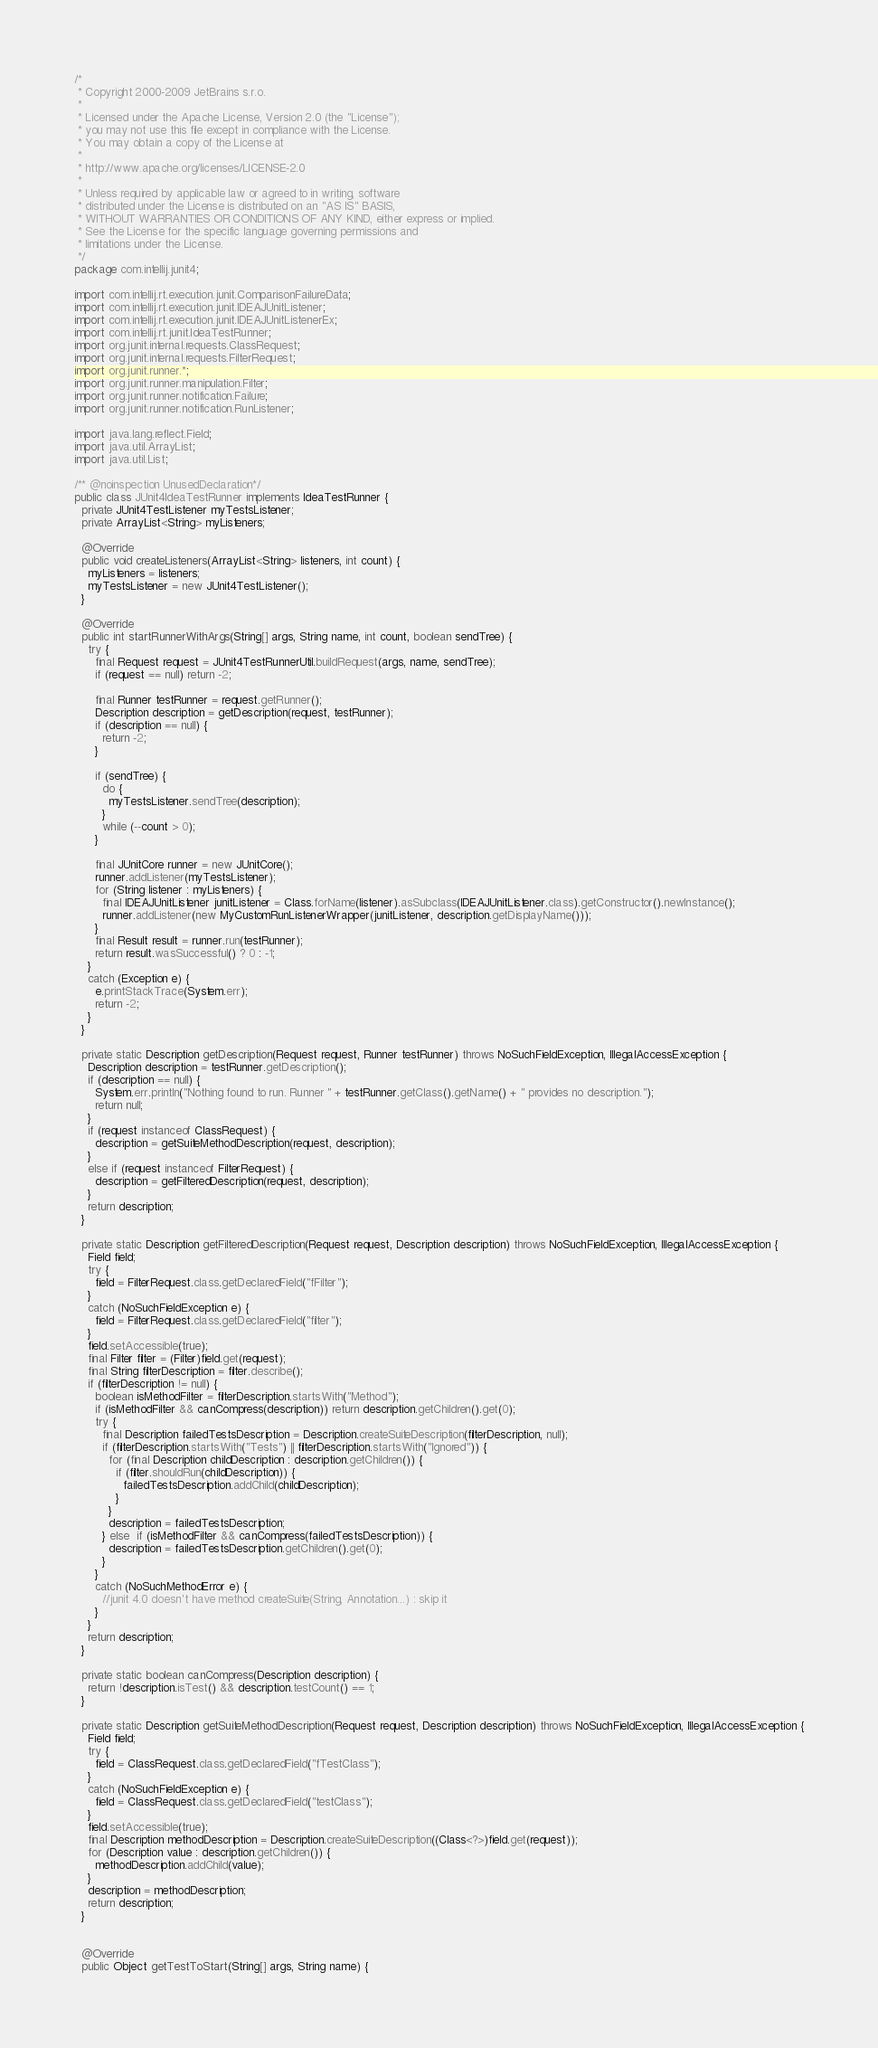<code> <loc_0><loc_0><loc_500><loc_500><_Java_>/*
 * Copyright 2000-2009 JetBrains s.r.o.
 *
 * Licensed under the Apache License, Version 2.0 (the "License");
 * you may not use this file except in compliance with the License.
 * You may obtain a copy of the License at
 *
 * http://www.apache.org/licenses/LICENSE-2.0
 *
 * Unless required by applicable law or agreed to in writing, software
 * distributed under the License is distributed on an "AS IS" BASIS,
 * WITHOUT WARRANTIES OR CONDITIONS OF ANY KIND, either express or implied.
 * See the License for the specific language governing permissions and
 * limitations under the License.
 */
package com.intellij.junit4;

import com.intellij.rt.execution.junit.ComparisonFailureData;
import com.intellij.rt.execution.junit.IDEAJUnitListener;
import com.intellij.rt.execution.junit.IDEAJUnitListenerEx;
import com.intellij.rt.junit.IdeaTestRunner;
import org.junit.internal.requests.ClassRequest;
import org.junit.internal.requests.FilterRequest;
import org.junit.runner.*;
import org.junit.runner.manipulation.Filter;
import org.junit.runner.notification.Failure;
import org.junit.runner.notification.RunListener;

import java.lang.reflect.Field;
import java.util.ArrayList;
import java.util.List;

/** @noinspection UnusedDeclaration*/
public class JUnit4IdeaTestRunner implements IdeaTestRunner {
  private JUnit4TestListener myTestsListener;
  private ArrayList<String> myListeners;

  @Override
  public void createListeners(ArrayList<String> listeners, int count) {
    myListeners = listeners;
    myTestsListener = new JUnit4TestListener();
  }

  @Override
  public int startRunnerWithArgs(String[] args, String name, int count, boolean sendTree) {
    try {
      final Request request = JUnit4TestRunnerUtil.buildRequest(args, name, sendTree);
      if (request == null) return -2;

      final Runner testRunner = request.getRunner();
      Description description = getDescription(request, testRunner);
      if (description == null) {
        return -2;
      }

      if (sendTree) {
        do {
          myTestsListener.sendTree(description);
        }
        while (--count > 0);
      }

      final JUnitCore runner = new JUnitCore();
      runner.addListener(myTestsListener);
      for (String listener : myListeners) {
        final IDEAJUnitListener junitListener = Class.forName(listener).asSubclass(IDEAJUnitListener.class).getConstructor().newInstance();
        runner.addListener(new MyCustomRunListenerWrapper(junitListener, description.getDisplayName()));
      }
      final Result result = runner.run(testRunner);
      return result.wasSuccessful() ? 0 : -1;
    }
    catch (Exception e) {
      e.printStackTrace(System.err);
      return -2;
    }
  }

  private static Description getDescription(Request request, Runner testRunner) throws NoSuchFieldException, IllegalAccessException {
    Description description = testRunner.getDescription();
    if (description == null) {
      System.err.println("Nothing found to run. Runner " + testRunner.getClass().getName() + " provides no description.");
      return null;
    }
    if (request instanceof ClassRequest) {
      description = getSuiteMethodDescription(request, description);
    }
    else if (request instanceof FilterRequest) {
      description = getFilteredDescription(request, description);
    }
    return description;
  }

  private static Description getFilteredDescription(Request request, Description description) throws NoSuchFieldException, IllegalAccessException {
    Field field;
    try {
      field = FilterRequest.class.getDeclaredField("fFilter");
    }
    catch (NoSuchFieldException e) {
      field = FilterRequest.class.getDeclaredField("filter");
    }
    field.setAccessible(true);
    final Filter filter = (Filter)field.get(request);
    final String filterDescription = filter.describe();
    if (filterDescription != null) {
      boolean isMethodFilter = filterDescription.startsWith("Method");
      if (isMethodFilter && canCompress(description)) return description.getChildren().get(0);
      try {
        final Description failedTestsDescription = Description.createSuiteDescription(filterDescription, null);
        if (filterDescription.startsWith("Tests") || filterDescription.startsWith("Ignored")) {
          for (final Description childDescription : description.getChildren()) {
            if (filter.shouldRun(childDescription)) {
              failedTestsDescription.addChild(childDescription);
            }
          }
          description = failedTestsDescription;
        } else  if (isMethodFilter && canCompress(failedTestsDescription)) {
          description = failedTestsDescription.getChildren().get(0);
        }
      }
      catch (NoSuchMethodError e) {
        //junit 4.0 doesn't have method createSuite(String, Annotation...) : skip it
      }
    }
    return description;
  }

  private static boolean canCompress(Description description) {
    return !description.isTest() && description.testCount() == 1;
  }

  private static Description getSuiteMethodDescription(Request request, Description description) throws NoSuchFieldException, IllegalAccessException {
    Field field;
    try {
      field = ClassRequest.class.getDeclaredField("fTestClass");
    }
    catch (NoSuchFieldException e) {
      field = ClassRequest.class.getDeclaredField("testClass");
    }
    field.setAccessible(true);
    final Description methodDescription = Description.createSuiteDescription((Class<?>)field.get(request));
    for (Description value : description.getChildren()) {
      methodDescription.addChild(value);
    }
    description = methodDescription;
    return description;
  }


  @Override
  public Object getTestToStart(String[] args, String name) {</code> 